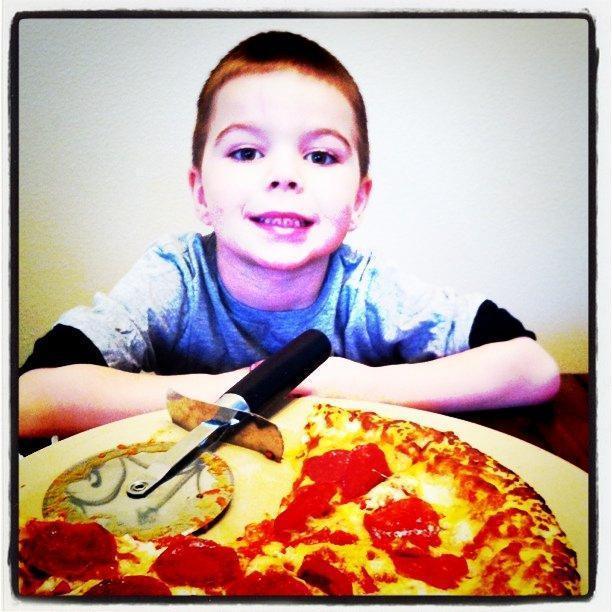How many people are there?
Give a very brief answer. 1. 